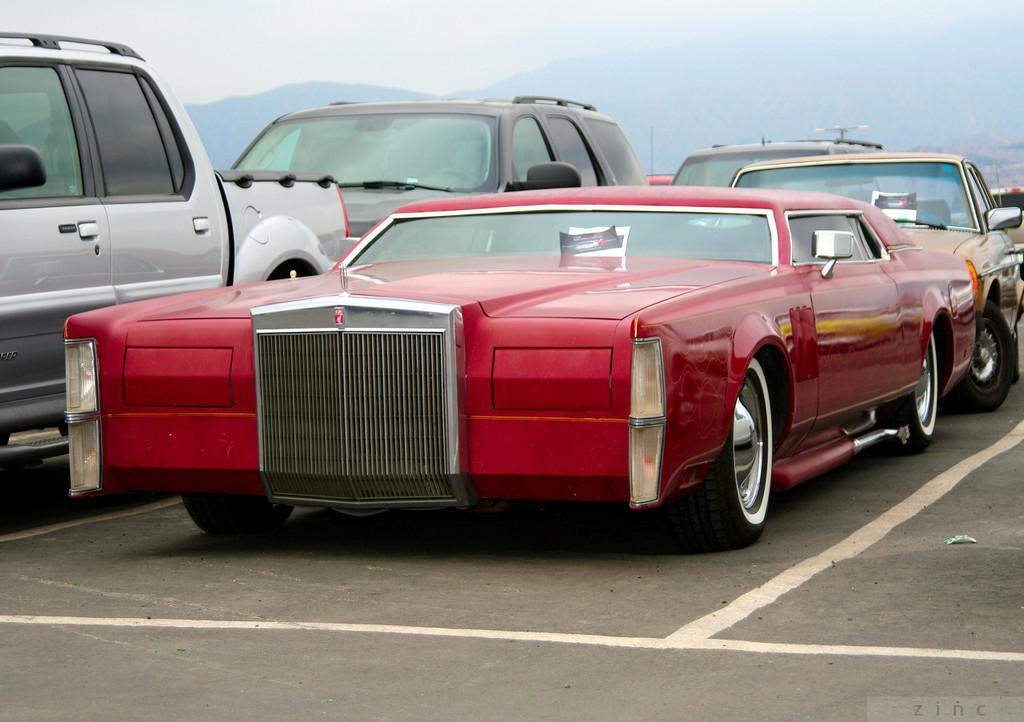What is happening in the image? There are vehicles on a road in the image. What can be seen in the distance in the image? There are mountains visible in the background of the image. What type of canvas is being used to paint the mountains in the image? There is no canvas or painting present in the image; it is a photograph of vehicles on a road with mountains in the background. How does the vehicle stop in the image? The image does not show the vehicles stopping; it only shows them on the road. 